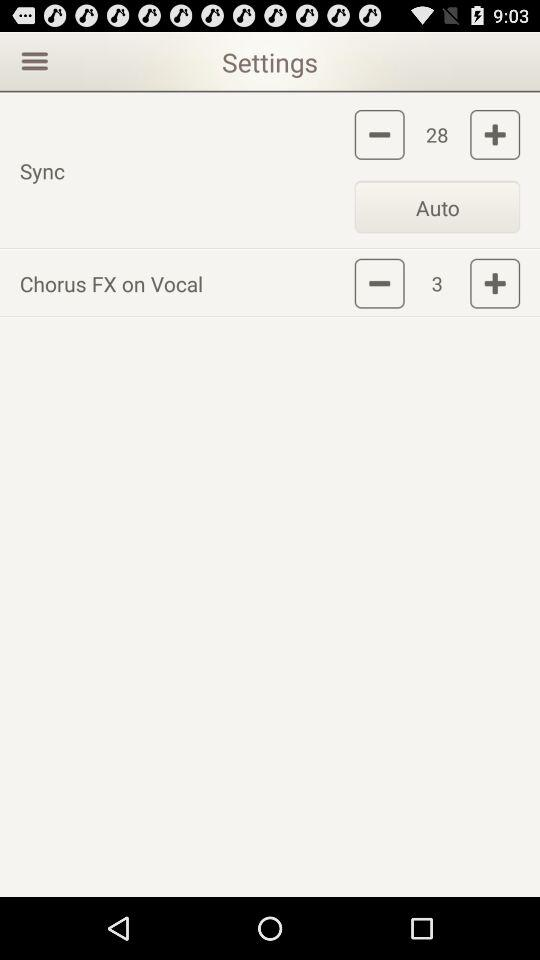What number is showing in sync? The number is 28. 